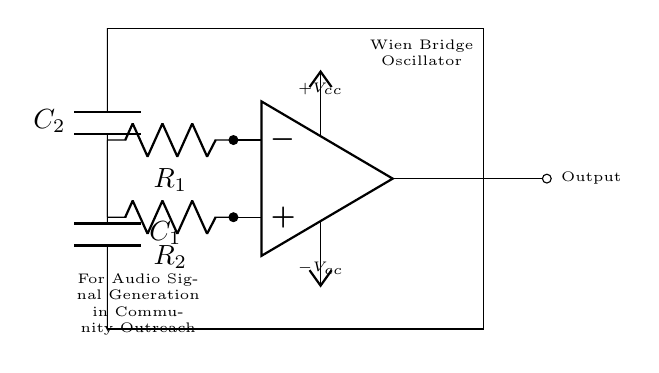What type of oscillator is depicted in the circuit? The circuit is labeled as a "Wien Bridge Oscillator," which is a specific type of oscillator known for generating sine waves.
Answer: Wien Bridge Oscillator What are the two key components providing feedback in the circuit? The feedback network in this oscillator primarily consists of two resistors and two capacitors, which are labeled as R1, R2, C1, and C2.
Answer: R1, R2, C1, C2 How many capacitors are present in this circuit? The diagram shows two capacitors, C1 and C2, which are part of the feedback network necessary for the frequency determination of the oscillator.
Answer: 2 What is the purpose of the op-amp in this circuit? The operational amplifier (op-amp) amplifies the voltage and ensures the oscillation occurs by providing the necessary gain and feedback.
Answer: Amplification What is the expected output of this Wien Bridge Oscillator? The output is typically a sine wave signal, as Wien Bridge Oscillators are designed to generate audio frequency signals for various applications.
Answer: Sine wave How does changing the values of R1 and C1 affect the circuit? Changing R1 and C1 alters the oscillation frequency, as the frequency is inversely proportional to the values of resistance and capacitance used in the circuit.
Answer: Frequency changes What kind of applications would benefit from this oscillator in community outreach programs? This oscillator can be used for audio signal generation in educational programs, sound therapy, or promoting auditory health awareness, where sound signals can serve specific purposes.
Answer: Audio signal generation 